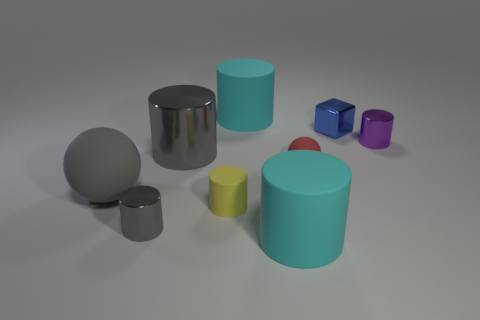What is the shape of the tiny blue thing that is made of the same material as the tiny purple cylinder?
Keep it short and to the point. Cube. There is a cylinder that is both in front of the purple object and behind the small ball; what material is it made of?
Keep it short and to the point. Metal. Do the large metal object and the large rubber ball have the same color?
Your answer should be compact. Yes. What shape is the small metallic object that is the same color as the big ball?
Keep it short and to the point. Cylinder. How many large rubber things are the same shape as the small purple thing?
Your answer should be very brief. 2. There is a yellow thing that is the same material as the red thing; what is its size?
Offer a very short reply. Small. Do the yellow cylinder and the gray rubber object have the same size?
Your response must be concise. No. Are any small brown metallic spheres visible?
Your answer should be very brief. No. There is a rubber object that is the same color as the large metallic cylinder; what is its size?
Ensure brevity in your answer.  Large. How big is the metallic cylinder that is to the right of the large cyan thing on the left side of the big cyan matte cylinder in front of the tiny yellow thing?
Give a very brief answer. Small. 